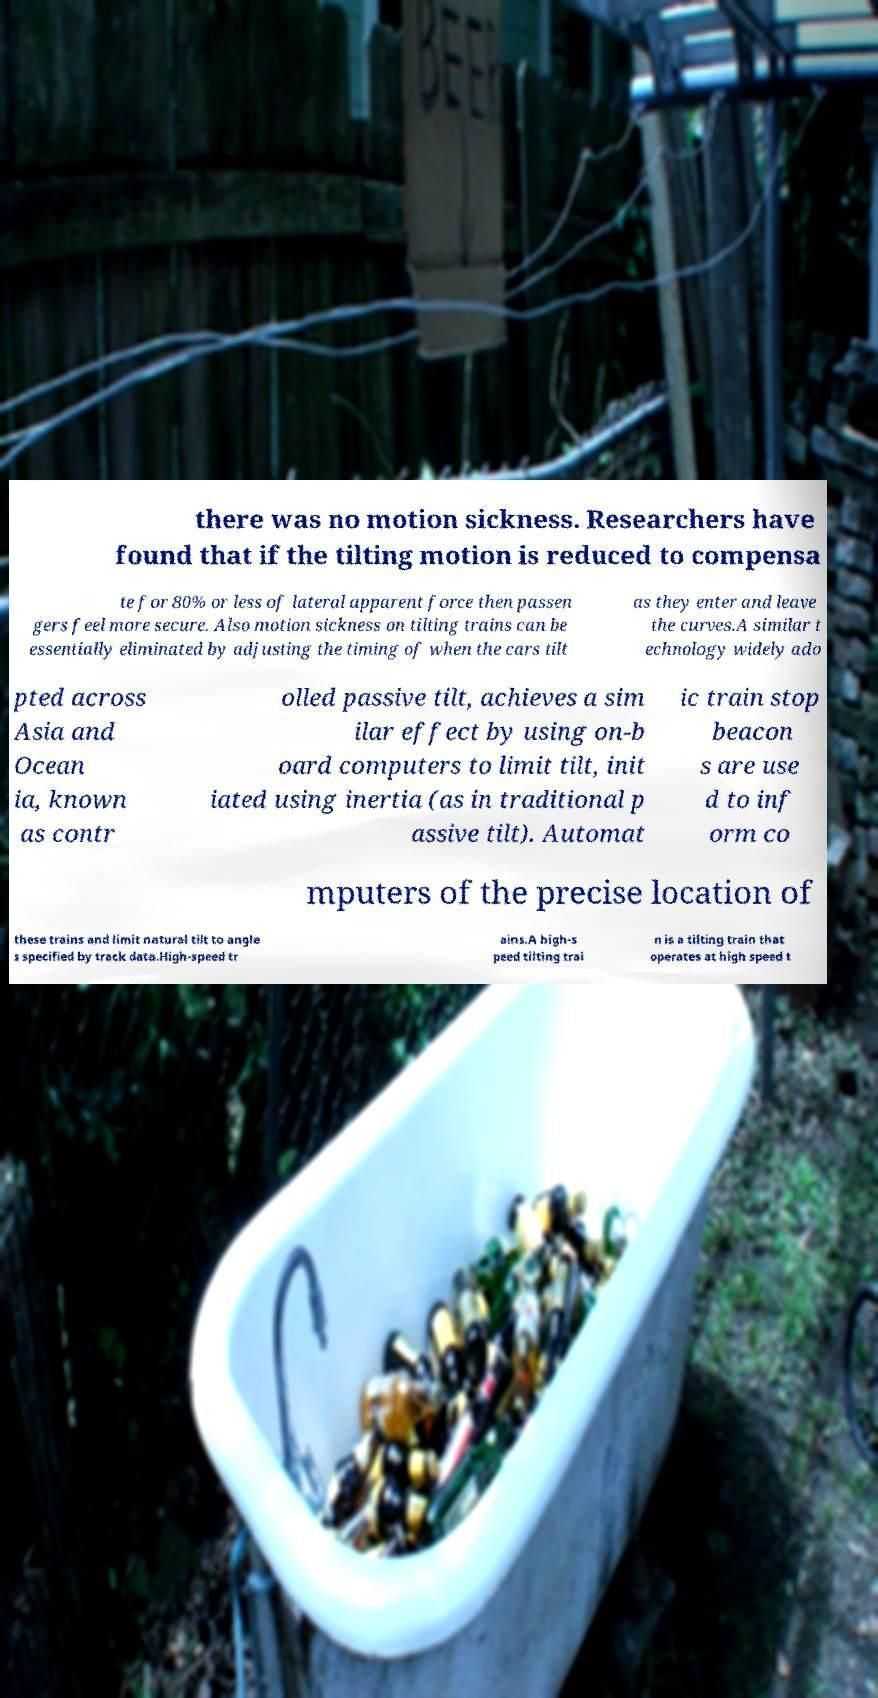Please read and relay the text visible in this image. What does it say? there was no motion sickness. Researchers have found that if the tilting motion is reduced to compensa te for 80% or less of lateral apparent force then passen gers feel more secure. Also motion sickness on tilting trains can be essentially eliminated by adjusting the timing of when the cars tilt as they enter and leave the curves.A similar t echnology widely ado pted across Asia and Ocean ia, known as contr olled passive tilt, achieves a sim ilar effect by using on-b oard computers to limit tilt, init iated using inertia (as in traditional p assive tilt). Automat ic train stop beacon s are use d to inf orm co mputers of the precise location of these trains and limit natural tilt to angle s specified by track data.High-speed tr ains.A high-s peed tilting trai n is a tilting train that operates at high speed t 